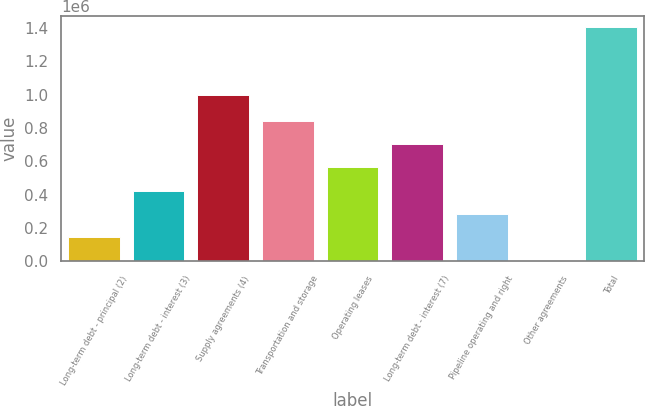<chart> <loc_0><loc_0><loc_500><loc_500><bar_chart><fcel>Long-term debt - principal (2)<fcel>Long-term debt - interest (3)<fcel>Supply agreements (4)<fcel>Transportation and storage<fcel>Operating leases<fcel>Long-term debt - interest (7)<fcel>Pipeline operating and right<fcel>Other agreements<fcel>Total<nl><fcel>143352<fcel>423279<fcel>995790<fcel>843170<fcel>563242<fcel>703206<fcel>283315<fcel>3388<fcel>1.40302e+06<nl></chart> 